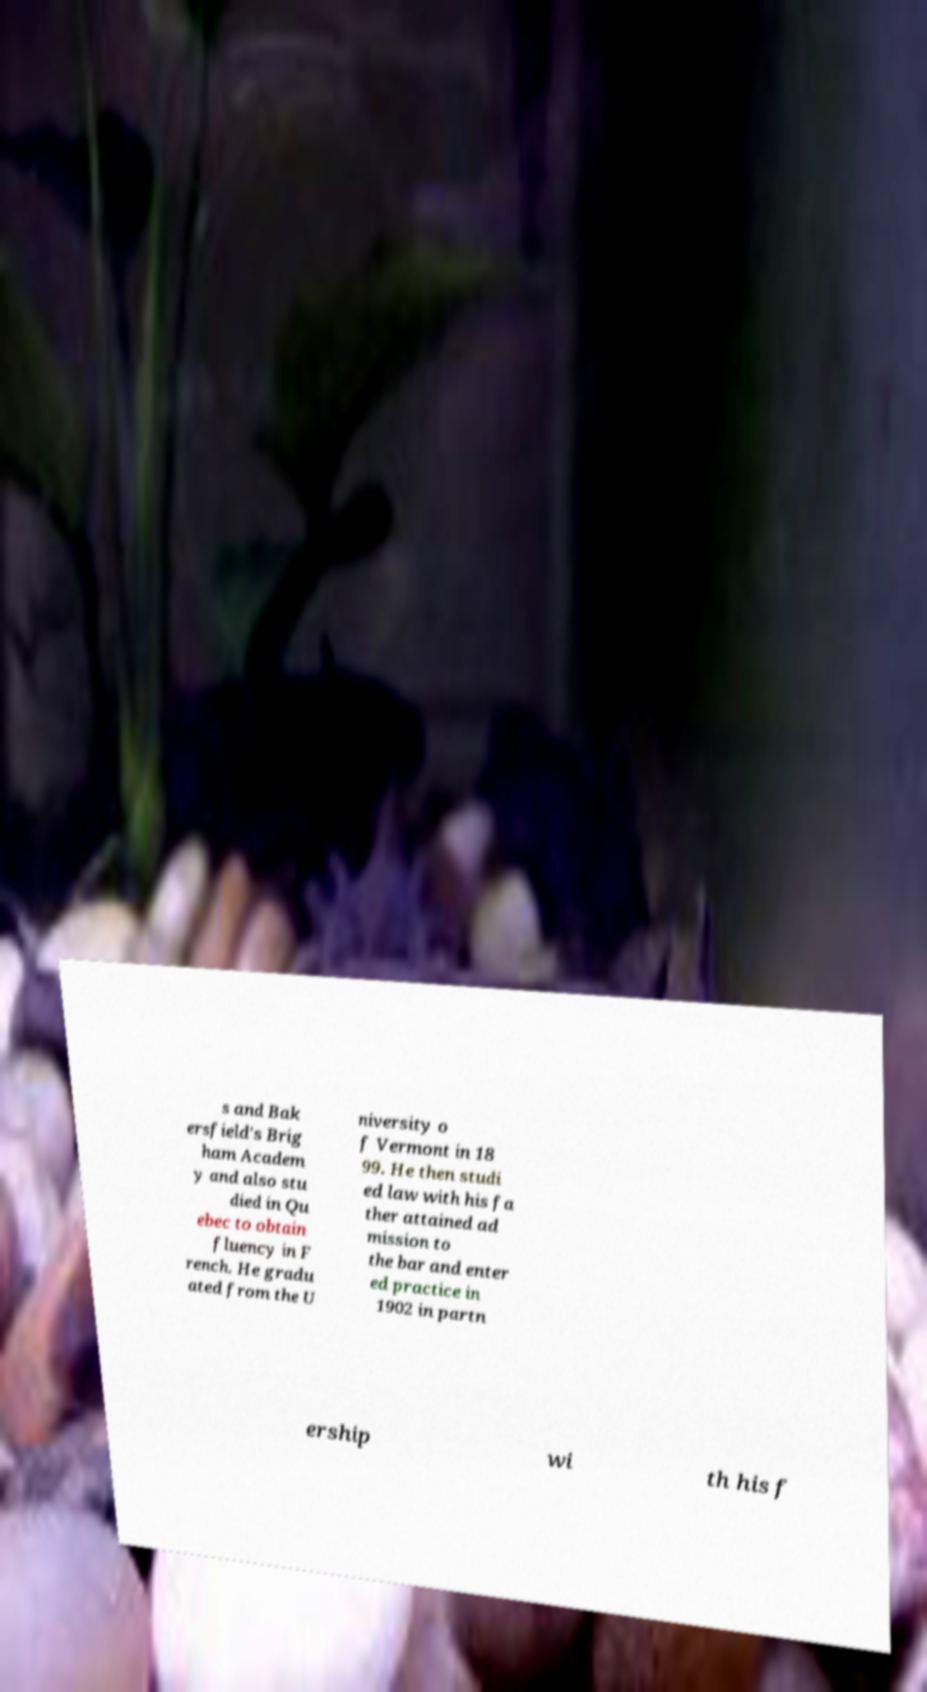Can you accurately transcribe the text from the provided image for me? s and Bak ersfield's Brig ham Academ y and also stu died in Qu ebec to obtain fluency in F rench. He gradu ated from the U niversity o f Vermont in 18 99. He then studi ed law with his fa ther attained ad mission to the bar and enter ed practice in 1902 in partn ership wi th his f 